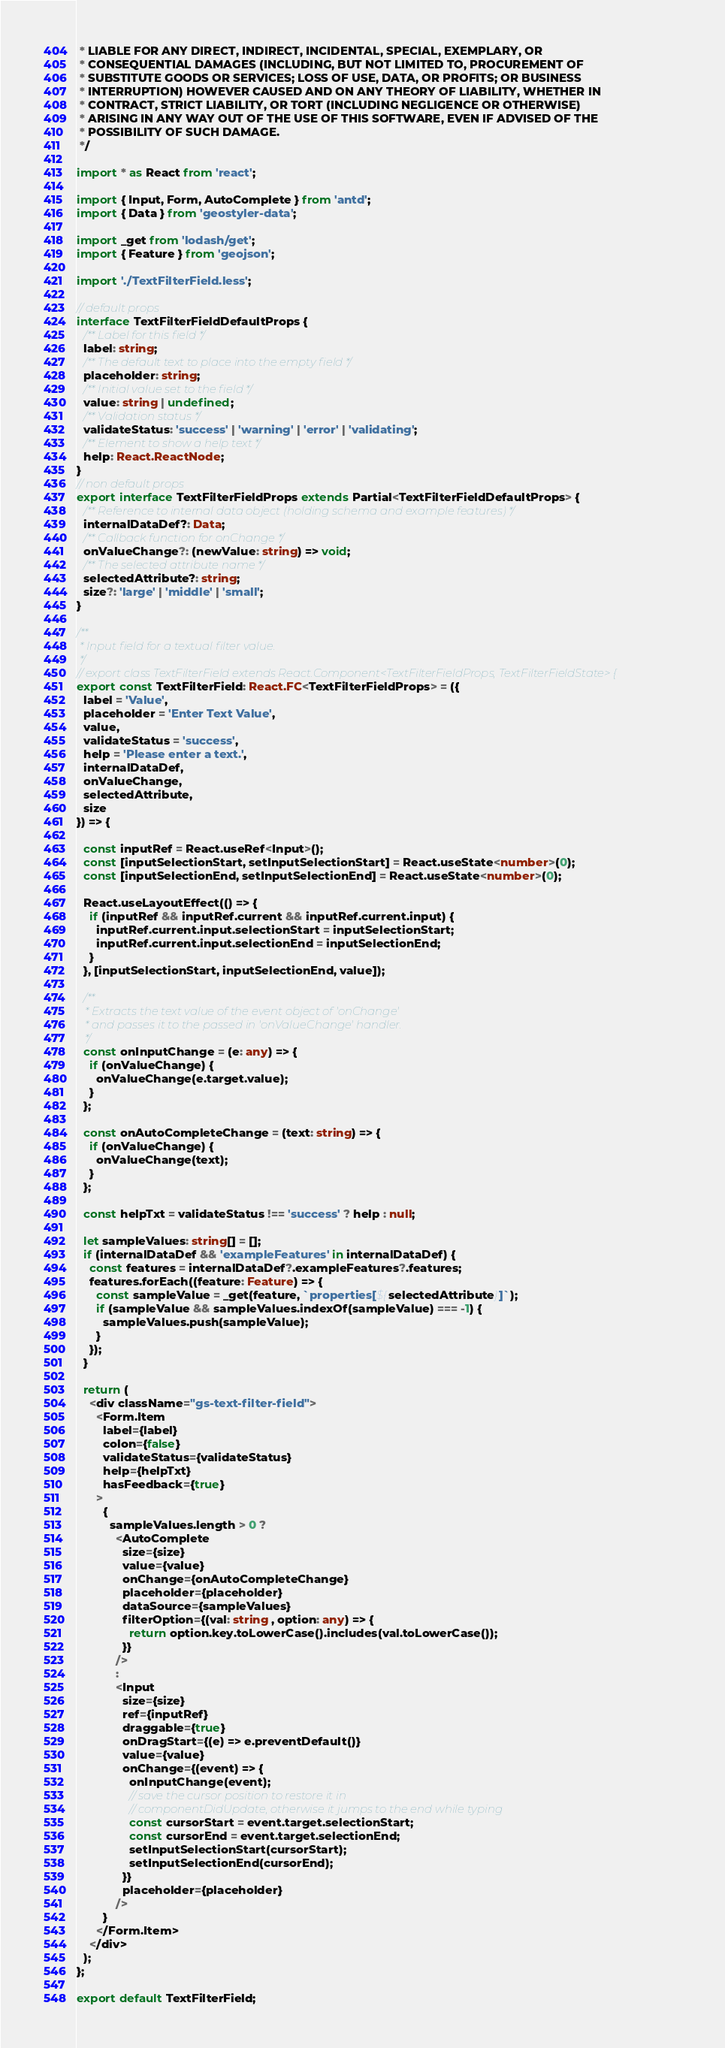Convert code to text. <code><loc_0><loc_0><loc_500><loc_500><_TypeScript_> * LIABLE FOR ANY DIRECT, INDIRECT, INCIDENTAL, SPECIAL, EXEMPLARY, OR
 * CONSEQUENTIAL DAMAGES (INCLUDING, BUT NOT LIMITED TO, PROCUREMENT OF
 * SUBSTITUTE GOODS OR SERVICES; LOSS OF USE, DATA, OR PROFITS; OR BUSINESS
 * INTERRUPTION) HOWEVER CAUSED AND ON ANY THEORY OF LIABILITY, WHETHER IN
 * CONTRACT, STRICT LIABILITY, OR TORT (INCLUDING NEGLIGENCE OR OTHERWISE)
 * ARISING IN ANY WAY OUT OF THE USE OF THIS SOFTWARE, EVEN IF ADVISED OF THE
 * POSSIBILITY OF SUCH DAMAGE.
 */

import * as React from 'react';

import { Input, Form, AutoComplete } from 'antd';
import { Data } from 'geostyler-data';

import _get from 'lodash/get';
import { Feature } from 'geojson';

import './TextFilterField.less';

// default props
interface TextFilterFieldDefaultProps {
  /** Label for this field */
  label: string;
  /** The default text to place into the empty field */
  placeholder: string;
  /** Initial value set to the field */
  value: string | undefined;
  /** Validation status */
  validateStatus: 'success' | 'warning' | 'error' | 'validating';
  /** Element to show a help text */
  help: React.ReactNode;
}
// non default props
export interface TextFilterFieldProps extends Partial<TextFilterFieldDefaultProps> {
  /** Reference to internal data object (holding schema and example features) */
  internalDataDef?: Data;
  /** Callback function for onChange */
  onValueChange?: (newValue: string) => void;
  /** The selected attribute name */
  selectedAttribute?: string;
  size?: 'large' | 'middle' | 'small';
}

/**
 * Input field for a textual filter value.
 */
// export class TextFilterField extends React.Component<TextFilterFieldProps, TextFilterFieldState> {
export const TextFilterField: React.FC<TextFilterFieldProps> = ({
  label = 'Value',
  placeholder = 'Enter Text Value',
  value,
  validateStatus = 'success',
  help = 'Please enter a text.',
  internalDataDef,
  onValueChange,
  selectedAttribute,
  size
}) => {

  const inputRef = React.useRef<Input>();
  const [inputSelectionStart, setInputSelectionStart] = React.useState<number>(0);
  const [inputSelectionEnd, setInputSelectionEnd] = React.useState<number>(0);

  React.useLayoutEffect(() => {
    if (inputRef && inputRef.current && inputRef.current.input) {
      inputRef.current.input.selectionStart = inputSelectionStart;
      inputRef.current.input.selectionEnd = inputSelectionEnd;
    }
  }, [inputSelectionStart, inputSelectionEnd, value]);

  /**
   * Extracts the text value of the event object of 'onChange'
   * and passes it to the passed in 'onValueChange' handler.
   */
  const onInputChange = (e: any) => {
    if (onValueChange) {
      onValueChange(e.target.value);
    }
  };

  const onAutoCompleteChange = (text: string) => {
    if (onValueChange) {
      onValueChange(text);
    }
  };

  const helpTxt = validateStatus !== 'success' ? help : null;

  let sampleValues: string[] = [];
  if (internalDataDef && 'exampleFeatures' in internalDataDef) {
    const features = internalDataDef?.exampleFeatures?.features;
    features.forEach((feature: Feature) => {
      const sampleValue = _get(feature, `properties[${selectedAttribute}]`);
      if (sampleValue && sampleValues.indexOf(sampleValue) === -1) {
        sampleValues.push(sampleValue);
      }
    });
  }

  return (
    <div className="gs-text-filter-field">
      <Form.Item
        label={label}
        colon={false}
        validateStatus={validateStatus}
        help={helpTxt}
        hasFeedback={true}
      >
        {
          sampleValues.length > 0 ?
            <AutoComplete
              size={size}
              value={value}
              onChange={onAutoCompleteChange}
              placeholder={placeholder}
              dataSource={sampleValues}
              filterOption={(val: string , option: any) => {
                return option.key.toLowerCase().includes(val.toLowerCase());
              }}
            />
            :
            <Input
              size={size}
              ref={inputRef}
              draggable={true}
              onDragStart={(e) => e.preventDefault()}
              value={value}
              onChange={(event) => {
                onInputChange(event);
                // save the cursor position to restore it in
                // componentDidUpdate, otherwise it jumps to the end while typing
                const cursorStart = event.target.selectionStart;
                const cursorEnd = event.target.selectionEnd;
                setInputSelectionStart(cursorStart);
                setInputSelectionEnd(cursorEnd);
              }}
              placeholder={placeholder}
            />
        }
      </Form.Item>
    </div>
  );
};

export default TextFilterField;
</code> 